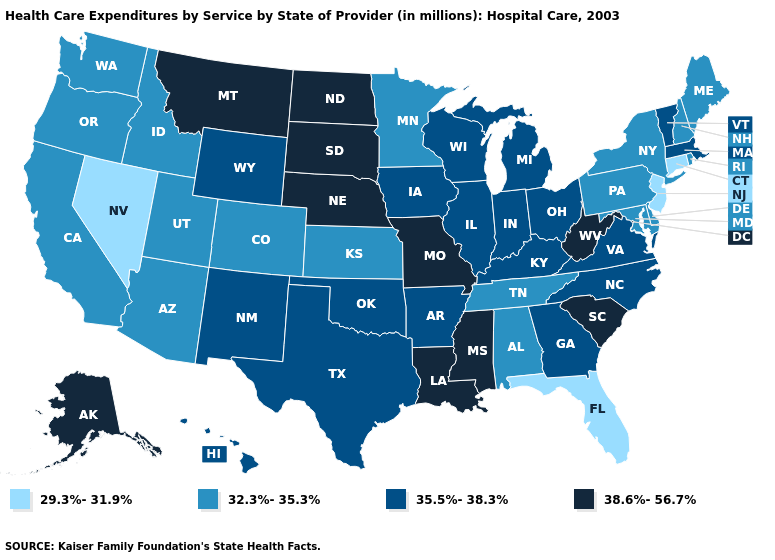Among the states that border Washington , which have the highest value?
Be succinct. Idaho, Oregon. How many symbols are there in the legend?
Be succinct. 4. Among the states that border Utah , which have the highest value?
Concise answer only. New Mexico, Wyoming. Does the map have missing data?
Keep it brief. No. Name the states that have a value in the range 38.6%-56.7%?
Quick response, please. Alaska, Louisiana, Mississippi, Missouri, Montana, Nebraska, North Dakota, South Carolina, South Dakota, West Virginia. Does Connecticut have the lowest value in the Northeast?
Give a very brief answer. Yes. What is the value of South Dakota?
Be succinct. 38.6%-56.7%. Among the states that border New Hampshire , which have the highest value?
Give a very brief answer. Massachusetts, Vermont. What is the lowest value in states that border Pennsylvania?
Short answer required. 29.3%-31.9%. What is the value of Illinois?
Concise answer only. 35.5%-38.3%. What is the value of Kansas?
Concise answer only. 32.3%-35.3%. Is the legend a continuous bar?
Answer briefly. No. Does the map have missing data?
Give a very brief answer. No. Is the legend a continuous bar?
Be succinct. No. Name the states that have a value in the range 35.5%-38.3%?
Write a very short answer. Arkansas, Georgia, Hawaii, Illinois, Indiana, Iowa, Kentucky, Massachusetts, Michigan, New Mexico, North Carolina, Ohio, Oklahoma, Texas, Vermont, Virginia, Wisconsin, Wyoming. 